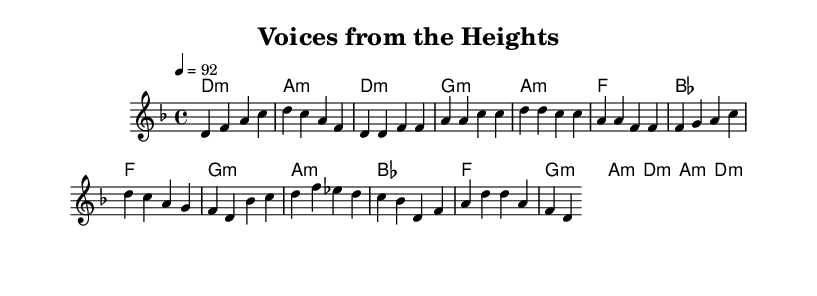What is the key signature of this music? The key signature is indicated by the absence of sharps or flats, which implies it is in D minor.
Answer: D minor What is the time signature of this music? The time signature is shown at the start of the piece as 4/4, meaning there are four beats in each measure.
Answer: 4/4 What is the tempo marking for this piece? The tempo marking indicates a speed of quarter note equals 92 beats per minute, which suggests a moderate pace for the performance.
Answer: 92 How many measures are there in the chorus section? By counting the measures laid out in the score, there are four measures in the chorus section.
Answer: 4 Which chord is played in the bridge section? The chords listed for the bridge are based on the harmony section, and can be identified as B flat major, F major, G minor, and A minor in that order.
Answer: B flat major, F major, G minor, A minor Is there a repeated section in this music? In analyzing the structure, the chorus section does repeat similar melodic and harmonic elements, indicating a repeated section.
Answer: Yes What genre does this piece belong to? The structure and lyrical content focusing on social issues suggests that this composition belongs to the political rap genre, which is a natural fit for the message conveyed.
Answer: Political rap 